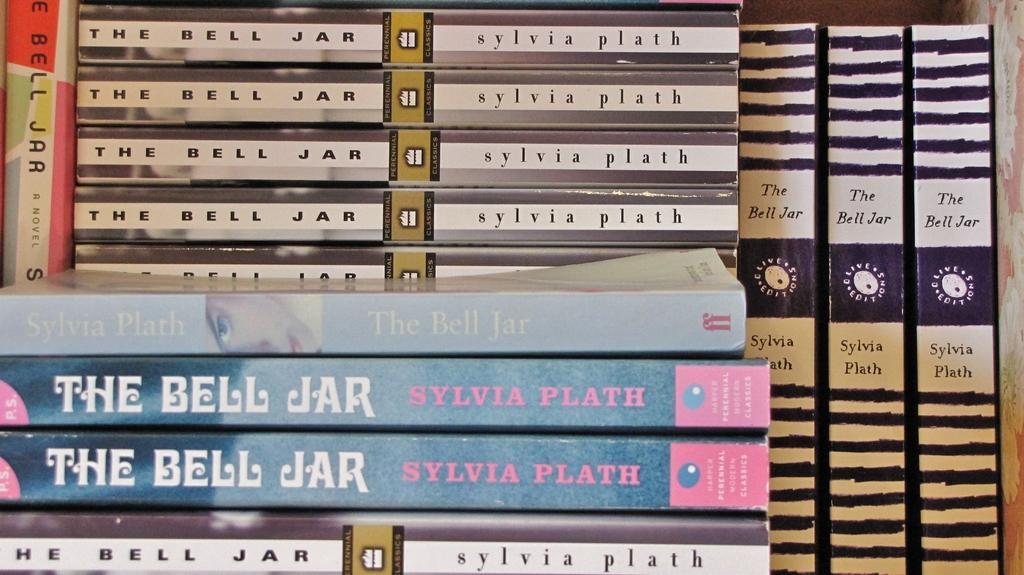<image>
Summarize the visual content of the image. Many different copies of The Bell Jar by Sylvia Plath. 